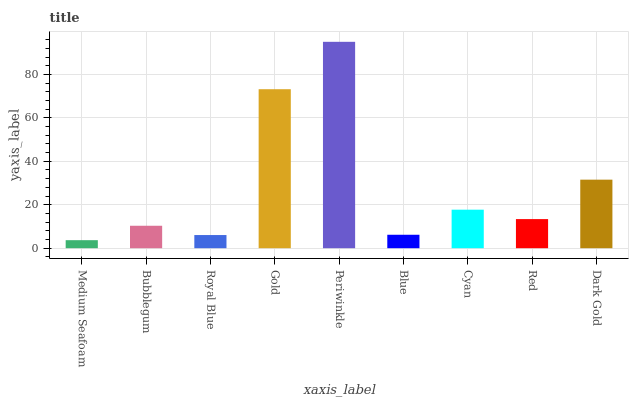Is Medium Seafoam the minimum?
Answer yes or no. Yes. Is Periwinkle the maximum?
Answer yes or no. Yes. Is Bubblegum the minimum?
Answer yes or no. No. Is Bubblegum the maximum?
Answer yes or no. No. Is Bubblegum greater than Medium Seafoam?
Answer yes or no. Yes. Is Medium Seafoam less than Bubblegum?
Answer yes or no. Yes. Is Medium Seafoam greater than Bubblegum?
Answer yes or no. No. Is Bubblegum less than Medium Seafoam?
Answer yes or no. No. Is Red the high median?
Answer yes or no. Yes. Is Red the low median?
Answer yes or no. Yes. Is Cyan the high median?
Answer yes or no. No. Is Royal Blue the low median?
Answer yes or no. No. 